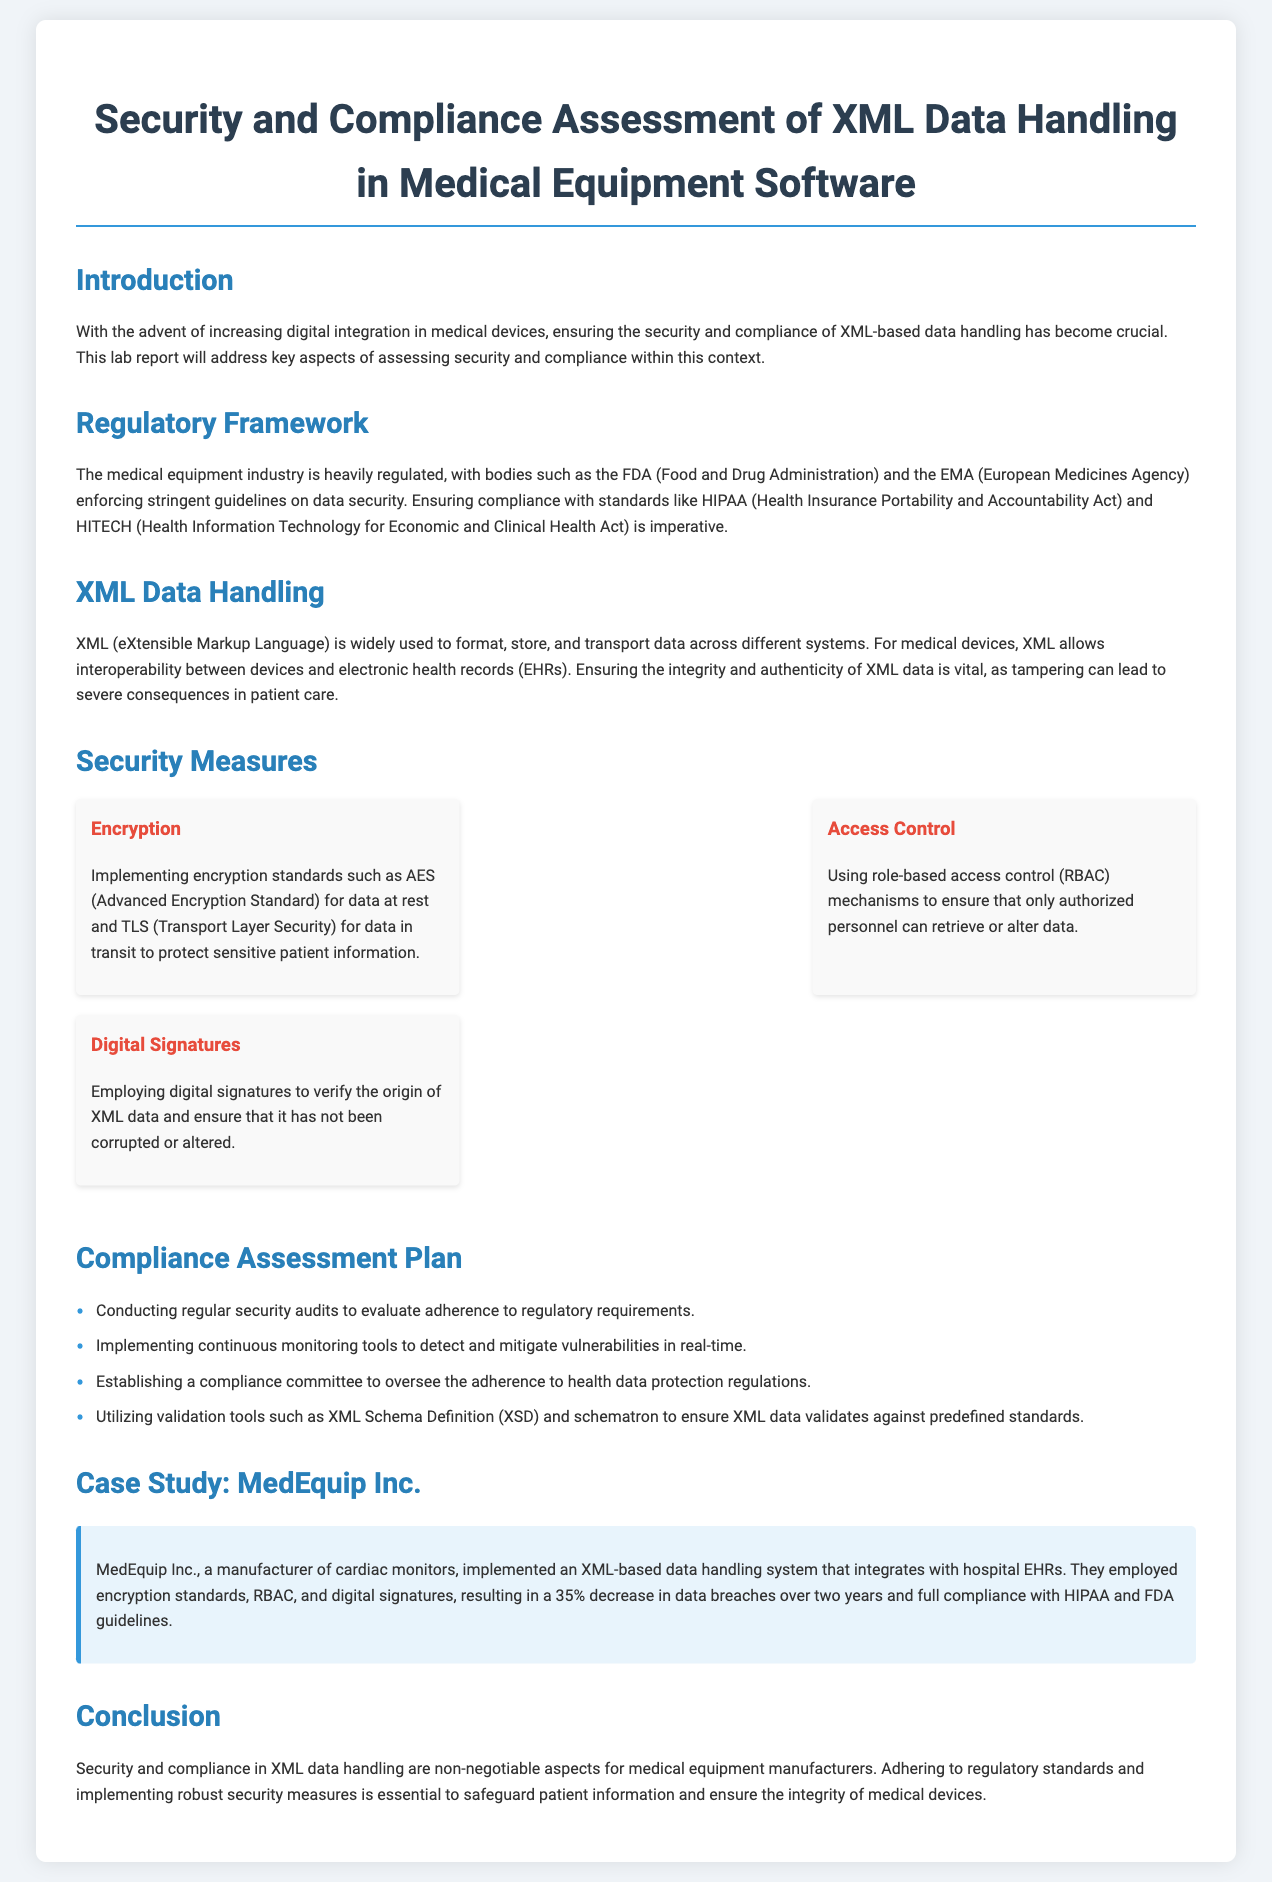What is the title of the report? The title is specified at the top of the document as it serves as the main heading, summarizing the focus of the content.
Answer: Security and Compliance Assessment of XML Data Handling in Medical Equipment Software Who enforces stringent guidelines on data security? The document mentions regulatory bodies responsible for monitoring data security in the medical equipment industry.
Answer: FDA and EMA What is one security measure mentioned in the document? The report lists various security measures that are implemented to safeguard XML data, highlighting key practices.
Answer: Encryption What is the compliance assessment plan for XML data handling? The document outlines steps taken to ensure compliance with health data protection regulations, including specific actions.
Answer: Conducting regular security audits What percentage decrease in data breaches did MedEquip Inc. achieve? The document provides a statistic regarding the effectiveness of security measures taken by MedEquip Inc. in reducing data breaches.
Answer: 35% 